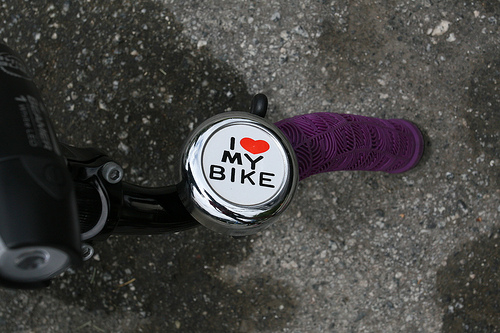<image>
Is there a heart above the letter? No. The heart is not positioned above the letter. The vertical arrangement shows a different relationship. 